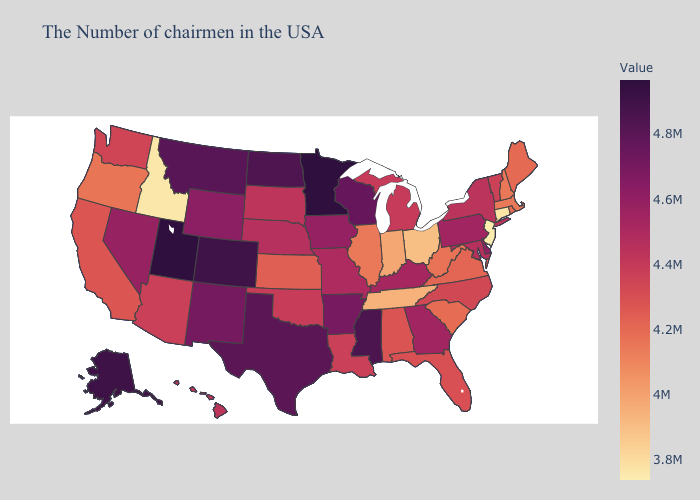Does New Jersey have the lowest value in the Northeast?
Short answer required. Yes. Does New Hampshire have a lower value than Idaho?
Concise answer only. No. Which states hav the highest value in the MidWest?
Keep it brief. Minnesota. Does Rhode Island have a lower value than Arkansas?
Quick response, please. Yes. Is the legend a continuous bar?
Concise answer only. Yes. Does Pennsylvania have a lower value than Utah?
Answer briefly. Yes. Among the states that border New York , which have the highest value?
Keep it brief. Pennsylvania. 